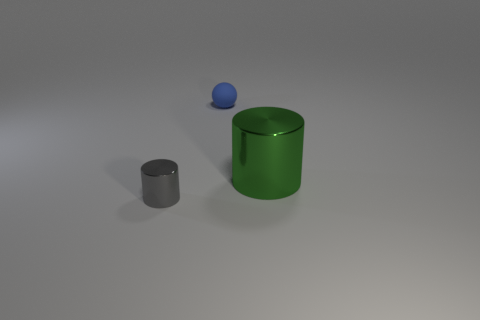Is there anything else that has the same material as the small blue object?
Make the answer very short. No. What number of other things are there of the same size as the blue rubber object?
Offer a terse response. 1. There is a cylinder behind the tiny thing that is left of the rubber object; what is its color?
Ensure brevity in your answer.  Green. Are there the same number of large green metal things to the left of the large green thing and things?
Offer a terse response. No. Is there another ball of the same size as the matte ball?
Keep it short and to the point. No. Does the matte ball have the same size as the shiny thing in front of the large thing?
Make the answer very short. Yes. Is the number of objects to the right of the blue ball the same as the number of blue rubber balls on the left side of the large green thing?
Your response must be concise. Yes. There is a small object behind the small gray cylinder; what is its material?
Provide a succinct answer. Rubber. Does the rubber object have the same size as the gray shiny object?
Your response must be concise. Yes. Is the number of small gray metallic cylinders that are behind the green cylinder greater than the number of big gray metallic cylinders?
Keep it short and to the point. No. 